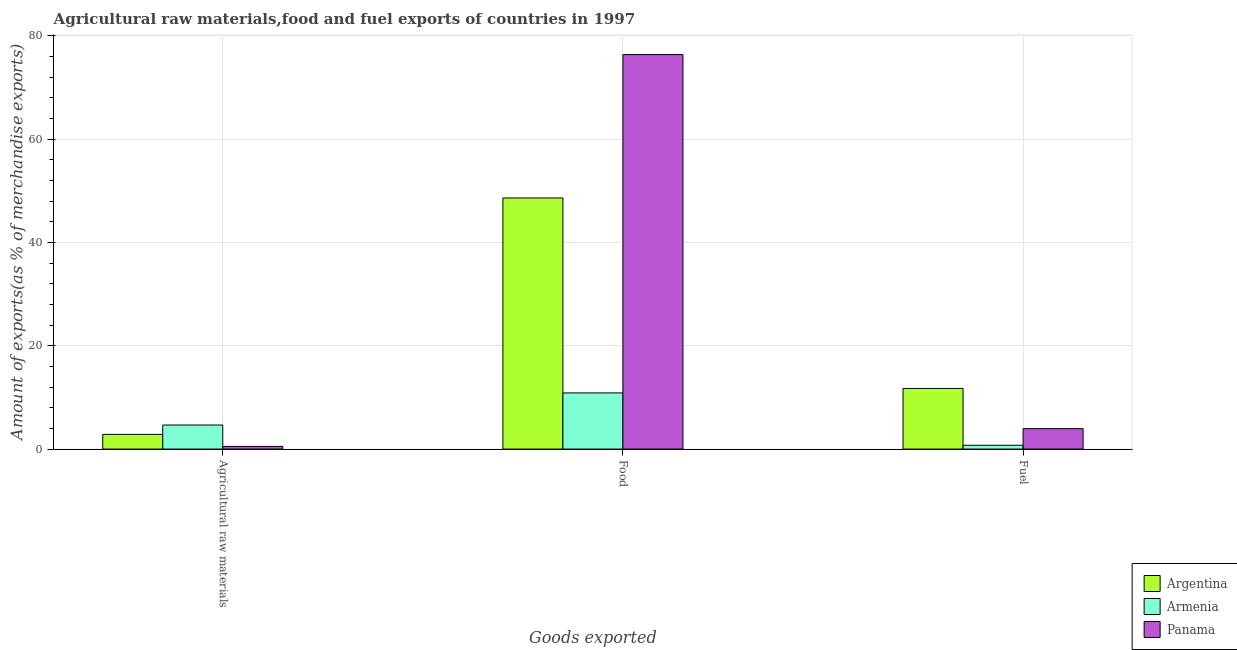How many different coloured bars are there?
Ensure brevity in your answer.  3. How many bars are there on the 1st tick from the left?
Keep it short and to the point. 3. What is the label of the 1st group of bars from the left?
Offer a terse response. Agricultural raw materials. What is the percentage of raw materials exports in Argentina?
Ensure brevity in your answer.  2.84. Across all countries, what is the maximum percentage of fuel exports?
Your response must be concise. 11.74. Across all countries, what is the minimum percentage of raw materials exports?
Your response must be concise. 0.51. In which country was the percentage of food exports maximum?
Provide a succinct answer. Panama. In which country was the percentage of food exports minimum?
Provide a short and direct response. Armenia. What is the total percentage of fuel exports in the graph?
Ensure brevity in your answer.  16.43. What is the difference between the percentage of raw materials exports in Argentina and that in Armenia?
Provide a short and direct response. -1.81. What is the difference between the percentage of food exports in Armenia and the percentage of fuel exports in Argentina?
Offer a very short reply. -0.86. What is the average percentage of food exports per country?
Give a very brief answer. 45.27. What is the difference between the percentage of food exports and percentage of fuel exports in Argentina?
Your answer should be compact. 36.87. In how many countries, is the percentage of raw materials exports greater than 56 %?
Your answer should be compact. 0. What is the ratio of the percentage of fuel exports in Argentina to that in Panama?
Give a very brief answer. 2.97. What is the difference between the highest and the second highest percentage of fuel exports?
Make the answer very short. 7.78. What is the difference between the highest and the lowest percentage of raw materials exports?
Provide a succinct answer. 4.14. Is the sum of the percentage of raw materials exports in Armenia and Panama greater than the maximum percentage of food exports across all countries?
Your response must be concise. No. What does the 2nd bar from the left in Fuel represents?
Make the answer very short. Armenia. What does the 1st bar from the right in Food represents?
Ensure brevity in your answer.  Panama. Are all the bars in the graph horizontal?
Your answer should be compact. No. How many countries are there in the graph?
Your response must be concise. 3. What is the difference between two consecutive major ticks on the Y-axis?
Keep it short and to the point. 20. Does the graph contain any zero values?
Provide a succinct answer. No. Does the graph contain grids?
Your answer should be compact. Yes. Where does the legend appear in the graph?
Make the answer very short. Bottom right. How many legend labels are there?
Offer a very short reply. 3. How are the legend labels stacked?
Provide a succinct answer. Vertical. What is the title of the graph?
Give a very brief answer. Agricultural raw materials,food and fuel exports of countries in 1997. What is the label or title of the X-axis?
Give a very brief answer. Goods exported. What is the label or title of the Y-axis?
Provide a short and direct response. Amount of exports(as % of merchandise exports). What is the Amount of exports(as % of merchandise exports) in Argentina in Agricultural raw materials?
Offer a terse response. 2.84. What is the Amount of exports(as % of merchandise exports) in Armenia in Agricultural raw materials?
Offer a very short reply. 4.66. What is the Amount of exports(as % of merchandise exports) of Panama in Agricultural raw materials?
Your answer should be very brief. 0.51. What is the Amount of exports(as % of merchandise exports) in Argentina in Food?
Your answer should be compact. 48.6. What is the Amount of exports(as % of merchandise exports) in Armenia in Food?
Ensure brevity in your answer.  10.87. What is the Amount of exports(as % of merchandise exports) in Panama in Food?
Provide a succinct answer. 76.35. What is the Amount of exports(as % of merchandise exports) of Argentina in Fuel?
Your response must be concise. 11.74. What is the Amount of exports(as % of merchandise exports) of Armenia in Fuel?
Keep it short and to the point. 0.74. What is the Amount of exports(as % of merchandise exports) in Panama in Fuel?
Ensure brevity in your answer.  3.96. Across all Goods exported, what is the maximum Amount of exports(as % of merchandise exports) in Argentina?
Offer a terse response. 48.6. Across all Goods exported, what is the maximum Amount of exports(as % of merchandise exports) of Armenia?
Ensure brevity in your answer.  10.87. Across all Goods exported, what is the maximum Amount of exports(as % of merchandise exports) of Panama?
Keep it short and to the point. 76.35. Across all Goods exported, what is the minimum Amount of exports(as % of merchandise exports) of Argentina?
Provide a succinct answer. 2.84. Across all Goods exported, what is the minimum Amount of exports(as % of merchandise exports) in Armenia?
Give a very brief answer. 0.74. Across all Goods exported, what is the minimum Amount of exports(as % of merchandise exports) of Panama?
Your response must be concise. 0.51. What is the total Amount of exports(as % of merchandise exports) of Argentina in the graph?
Offer a terse response. 63.18. What is the total Amount of exports(as % of merchandise exports) in Armenia in the graph?
Give a very brief answer. 16.27. What is the total Amount of exports(as % of merchandise exports) of Panama in the graph?
Your response must be concise. 80.82. What is the difference between the Amount of exports(as % of merchandise exports) of Argentina in Agricultural raw materials and that in Food?
Give a very brief answer. -45.76. What is the difference between the Amount of exports(as % of merchandise exports) in Armenia in Agricultural raw materials and that in Food?
Your response must be concise. -6.21. What is the difference between the Amount of exports(as % of merchandise exports) in Panama in Agricultural raw materials and that in Food?
Make the answer very short. -75.83. What is the difference between the Amount of exports(as % of merchandise exports) in Argentina in Agricultural raw materials and that in Fuel?
Offer a very short reply. -8.89. What is the difference between the Amount of exports(as % of merchandise exports) of Armenia in Agricultural raw materials and that in Fuel?
Offer a terse response. 3.92. What is the difference between the Amount of exports(as % of merchandise exports) of Panama in Agricultural raw materials and that in Fuel?
Make the answer very short. -3.44. What is the difference between the Amount of exports(as % of merchandise exports) in Argentina in Food and that in Fuel?
Provide a short and direct response. 36.87. What is the difference between the Amount of exports(as % of merchandise exports) in Armenia in Food and that in Fuel?
Give a very brief answer. 10.13. What is the difference between the Amount of exports(as % of merchandise exports) in Panama in Food and that in Fuel?
Provide a short and direct response. 72.39. What is the difference between the Amount of exports(as % of merchandise exports) of Argentina in Agricultural raw materials and the Amount of exports(as % of merchandise exports) of Armenia in Food?
Offer a terse response. -8.03. What is the difference between the Amount of exports(as % of merchandise exports) of Argentina in Agricultural raw materials and the Amount of exports(as % of merchandise exports) of Panama in Food?
Give a very brief answer. -73.51. What is the difference between the Amount of exports(as % of merchandise exports) of Armenia in Agricultural raw materials and the Amount of exports(as % of merchandise exports) of Panama in Food?
Your answer should be very brief. -71.69. What is the difference between the Amount of exports(as % of merchandise exports) in Argentina in Agricultural raw materials and the Amount of exports(as % of merchandise exports) in Armenia in Fuel?
Provide a succinct answer. 2.1. What is the difference between the Amount of exports(as % of merchandise exports) of Argentina in Agricultural raw materials and the Amount of exports(as % of merchandise exports) of Panama in Fuel?
Ensure brevity in your answer.  -1.11. What is the difference between the Amount of exports(as % of merchandise exports) of Argentina in Food and the Amount of exports(as % of merchandise exports) of Armenia in Fuel?
Your response must be concise. 47.86. What is the difference between the Amount of exports(as % of merchandise exports) in Argentina in Food and the Amount of exports(as % of merchandise exports) in Panama in Fuel?
Keep it short and to the point. 44.65. What is the difference between the Amount of exports(as % of merchandise exports) in Armenia in Food and the Amount of exports(as % of merchandise exports) in Panama in Fuel?
Your response must be concise. 6.91. What is the average Amount of exports(as % of merchandise exports) in Argentina per Goods exported?
Provide a short and direct response. 21.06. What is the average Amount of exports(as % of merchandise exports) of Armenia per Goods exported?
Keep it short and to the point. 5.42. What is the average Amount of exports(as % of merchandise exports) in Panama per Goods exported?
Your response must be concise. 26.94. What is the difference between the Amount of exports(as % of merchandise exports) in Argentina and Amount of exports(as % of merchandise exports) in Armenia in Agricultural raw materials?
Your answer should be very brief. -1.81. What is the difference between the Amount of exports(as % of merchandise exports) in Argentina and Amount of exports(as % of merchandise exports) in Panama in Agricultural raw materials?
Keep it short and to the point. 2.33. What is the difference between the Amount of exports(as % of merchandise exports) in Armenia and Amount of exports(as % of merchandise exports) in Panama in Agricultural raw materials?
Make the answer very short. 4.14. What is the difference between the Amount of exports(as % of merchandise exports) in Argentina and Amount of exports(as % of merchandise exports) in Armenia in Food?
Give a very brief answer. 37.73. What is the difference between the Amount of exports(as % of merchandise exports) in Argentina and Amount of exports(as % of merchandise exports) in Panama in Food?
Provide a short and direct response. -27.75. What is the difference between the Amount of exports(as % of merchandise exports) of Armenia and Amount of exports(as % of merchandise exports) of Panama in Food?
Give a very brief answer. -65.48. What is the difference between the Amount of exports(as % of merchandise exports) in Argentina and Amount of exports(as % of merchandise exports) in Armenia in Fuel?
Your answer should be very brief. 10.99. What is the difference between the Amount of exports(as % of merchandise exports) in Argentina and Amount of exports(as % of merchandise exports) in Panama in Fuel?
Keep it short and to the point. 7.78. What is the difference between the Amount of exports(as % of merchandise exports) in Armenia and Amount of exports(as % of merchandise exports) in Panama in Fuel?
Your answer should be very brief. -3.22. What is the ratio of the Amount of exports(as % of merchandise exports) of Argentina in Agricultural raw materials to that in Food?
Keep it short and to the point. 0.06. What is the ratio of the Amount of exports(as % of merchandise exports) in Armenia in Agricultural raw materials to that in Food?
Keep it short and to the point. 0.43. What is the ratio of the Amount of exports(as % of merchandise exports) in Panama in Agricultural raw materials to that in Food?
Make the answer very short. 0.01. What is the ratio of the Amount of exports(as % of merchandise exports) of Argentina in Agricultural raw materials to that in Fuel?
Provide a succinct answer. 0.24. What is the ratio of the Amount of exports(as % of merchandise exports) in Armenia in Agricultural raw materials to that in Fuel?
Your answer should be compact. 6.29. What is the ratio of the Amount of exports(as % of merchandise exports) in Panama in Agricultural raw materials to that in Fuel?
Your answer should be compact. 0.13. What is the ratio of the Amount of exports(as % of merchandise exports) in Argentina in Food to that in Fuel?
Give a very brief answer. 4.14. What is the ratio of the Amount of exports(as % of merchandise exports) in Armenia in Food to that in Fuel?
Offer a terse response. 14.68. What is the ratio of the Amount of exports(as % of merchandise exports) of Panama in Food to that in Fuel?
Ensure brevity in your answer.  19.3. What is the difference between the highest and the second highest Amount of exports(as % of merchandise exports) of Argentina?
Your answer should be compact. 36.87. What is the difference between the highest and the second highest Amount of exports(as % of merchandise exports) in Armenia?
Your answer should be very brief. 6.21. What is the difference between the highest and the second highest Amount of exports(as % of merchandise exports) in Panama?
Provide a succinct answer. 72.39. What is the difference between the highest and the lowest Amount of exports(as % of merchandise exports) of Argentina?
Your response must be concise. 45.76. What is the difference between the highest and the lowest Amount of exports(as % of merchandise exports) of Armenia?
Provide a short and direct response. 10.13. What is the difference between the highest and the lowest Amount of exports(as % of merchandise exports) of Panama?
Give a very brief answer. 75.83. 